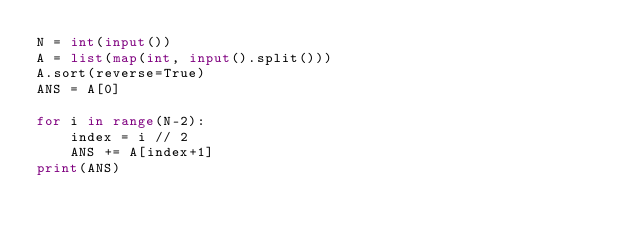Convert code to text. <code><loc_0><loc_0><loc_500><loc_500><_Python_>N = int(input())
A = list(map(int, input().split()))
A.sort(reverse=True)
ANS = A[0]

for i in range(N-2):
    index = i // 2
    ANS += A[index+1]
print(ANS)</code> 